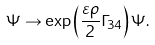Convert formula to latex. <formula><loc_0><loc_0><loc_500><loc_500>\Psi \to \exp \left ( \frac { \varepsilon \rho } { 2 } \Gamma _ { 3 4 } \right ) \Psi .</formula> 